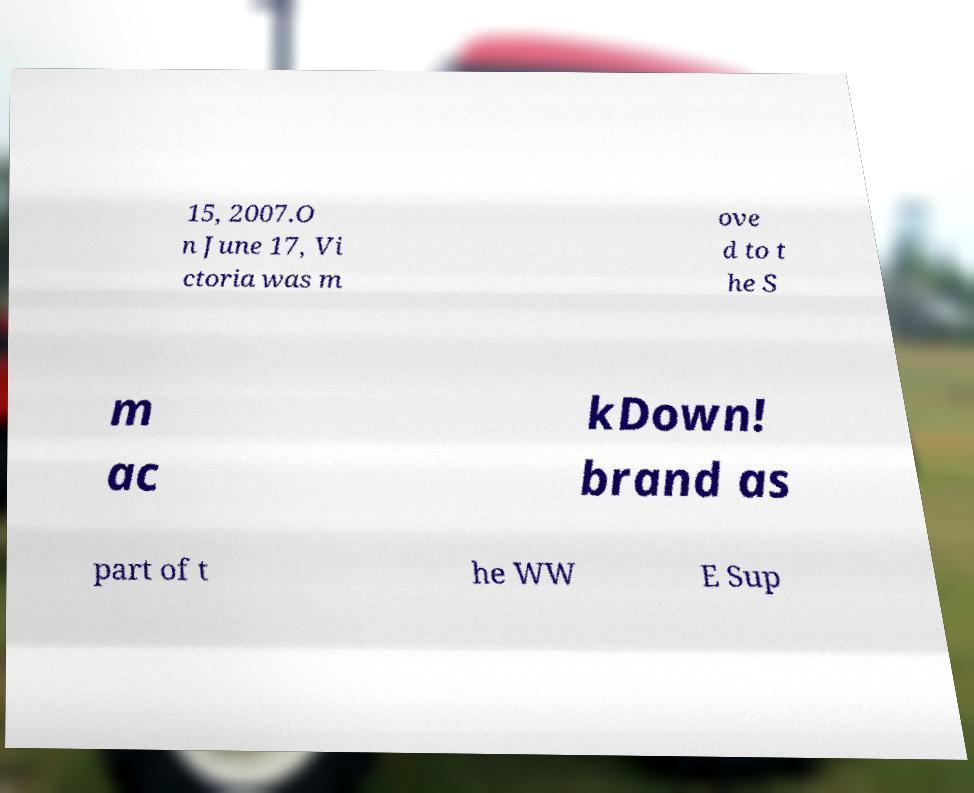Please read and relay the text visible in this image. What does it say? 15, 2007.O n June 17, Vi ctoria was m ove d to t he S m ac kDown! brand as part of t he WW E Sup 